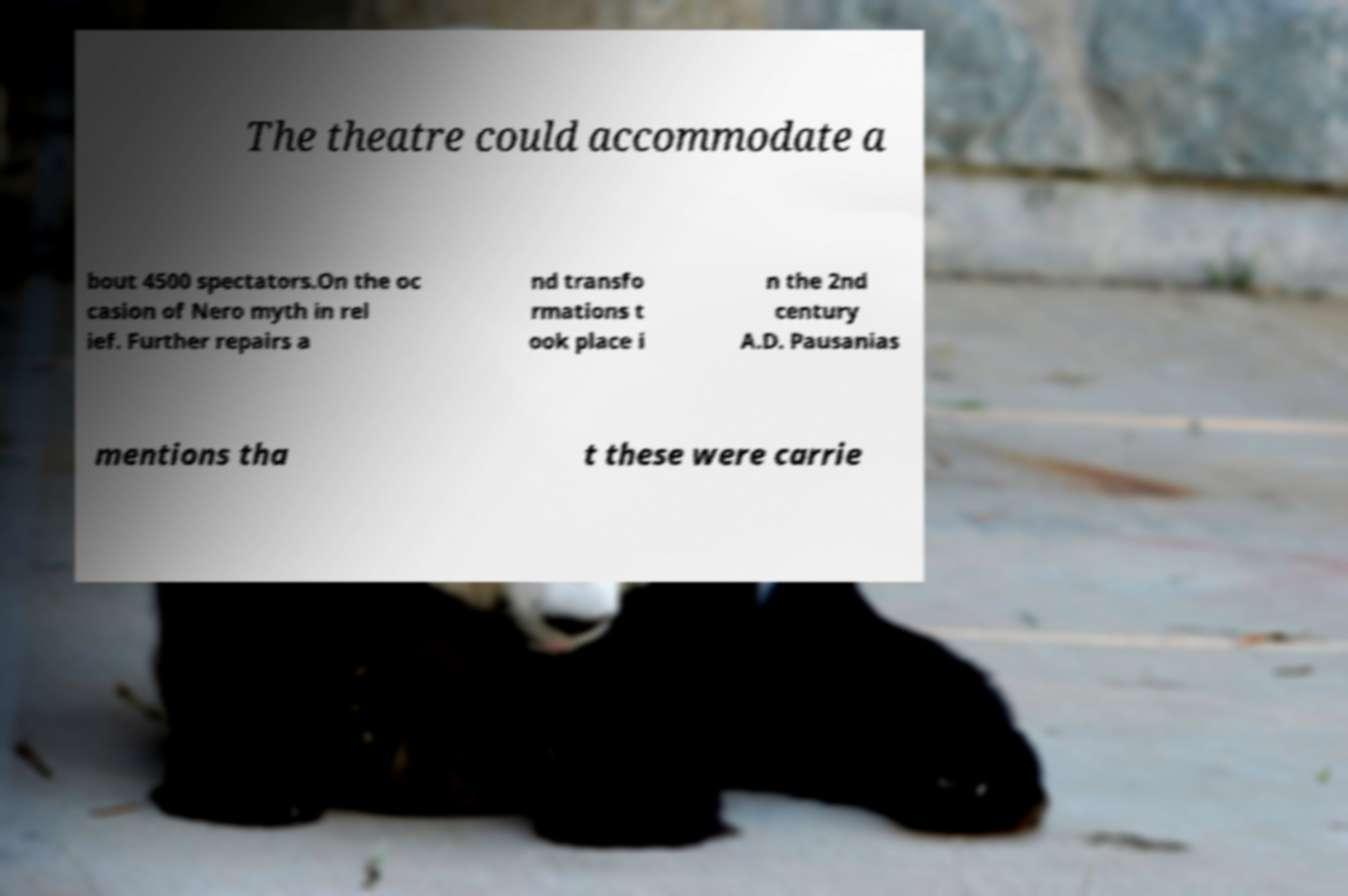Please read and relay the text visible in this image. What does it say? The theatre could accommodate a bout 4500 spectators.On the oc casion of Nero myth in rel ief. Further repairs a nd transfo rmations t ook place i n the 2nd century A.D. Pausanias mentions tha t these were carrie 